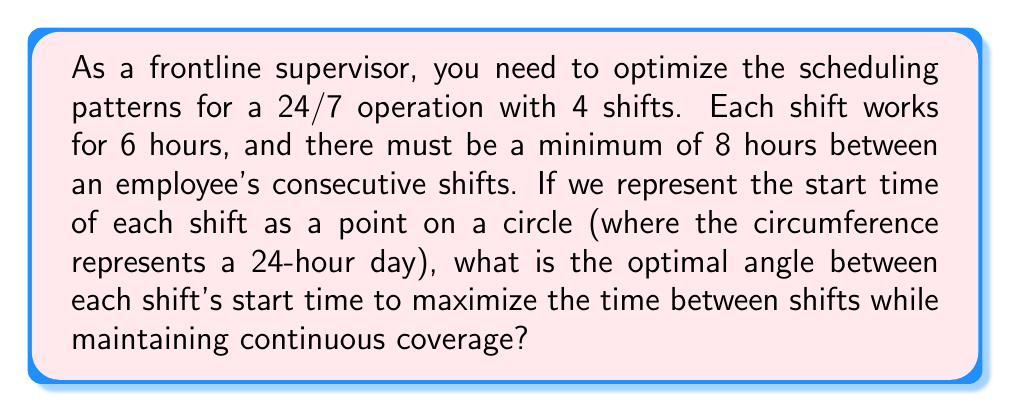What is the answer to this math problem? Let's approach this step-by-step:

1) First, we need to understand that the circle represents a 24-hour day, so 360° corresponds to 24 hours.

2) We have 4 shifts, so we need to divide the circle into 4 equal parts. The angle between each shift will be:

   $$\theta = \frac{360°}{4} = 90°$$

3) To convert this angle to time, we can use the proportion:
   
   $$\frac{90°}{x \text{ hours}} = \frac{360°}{24 \text{ hours}}$$

4) Solving for x:
   
   $$x = \frac{90° \times 24 \text{ hours}}{360°} = 6 \text{ hours}$$

5) This means each shift starts 6 hours after the previous one, which aligns with our 6-hour shift duration.

6) To visualize this, we can use a geometric representation:

   [asy]
   import geometry;

   size(200);
   
   pair O=(0,0);
   real r=1;
   
   draw(circle(O,r));
   
   for(int i=0; i<4; ++i) {
     pair P=r*dir(90*i);
     dot(P);
     label("Shift "+(string)(i+1),P,P);
   }
   
   draw(O--r*dir(0),Arrow);
   draw(O--r*dir(90),Arrow);
   draw(O--r*dir(180),Arrow);
   draw(O--r*dir(270),Arrow);
   
   label("90°",0.7*r*dir(45));
   [/asy]

7) This arrangement ensures that there are always 18 hours between an employee's consecutive shifts (3 x 6-hour intervals), which exceeds the minimum 8-hour requirement.
Answer: 90° 